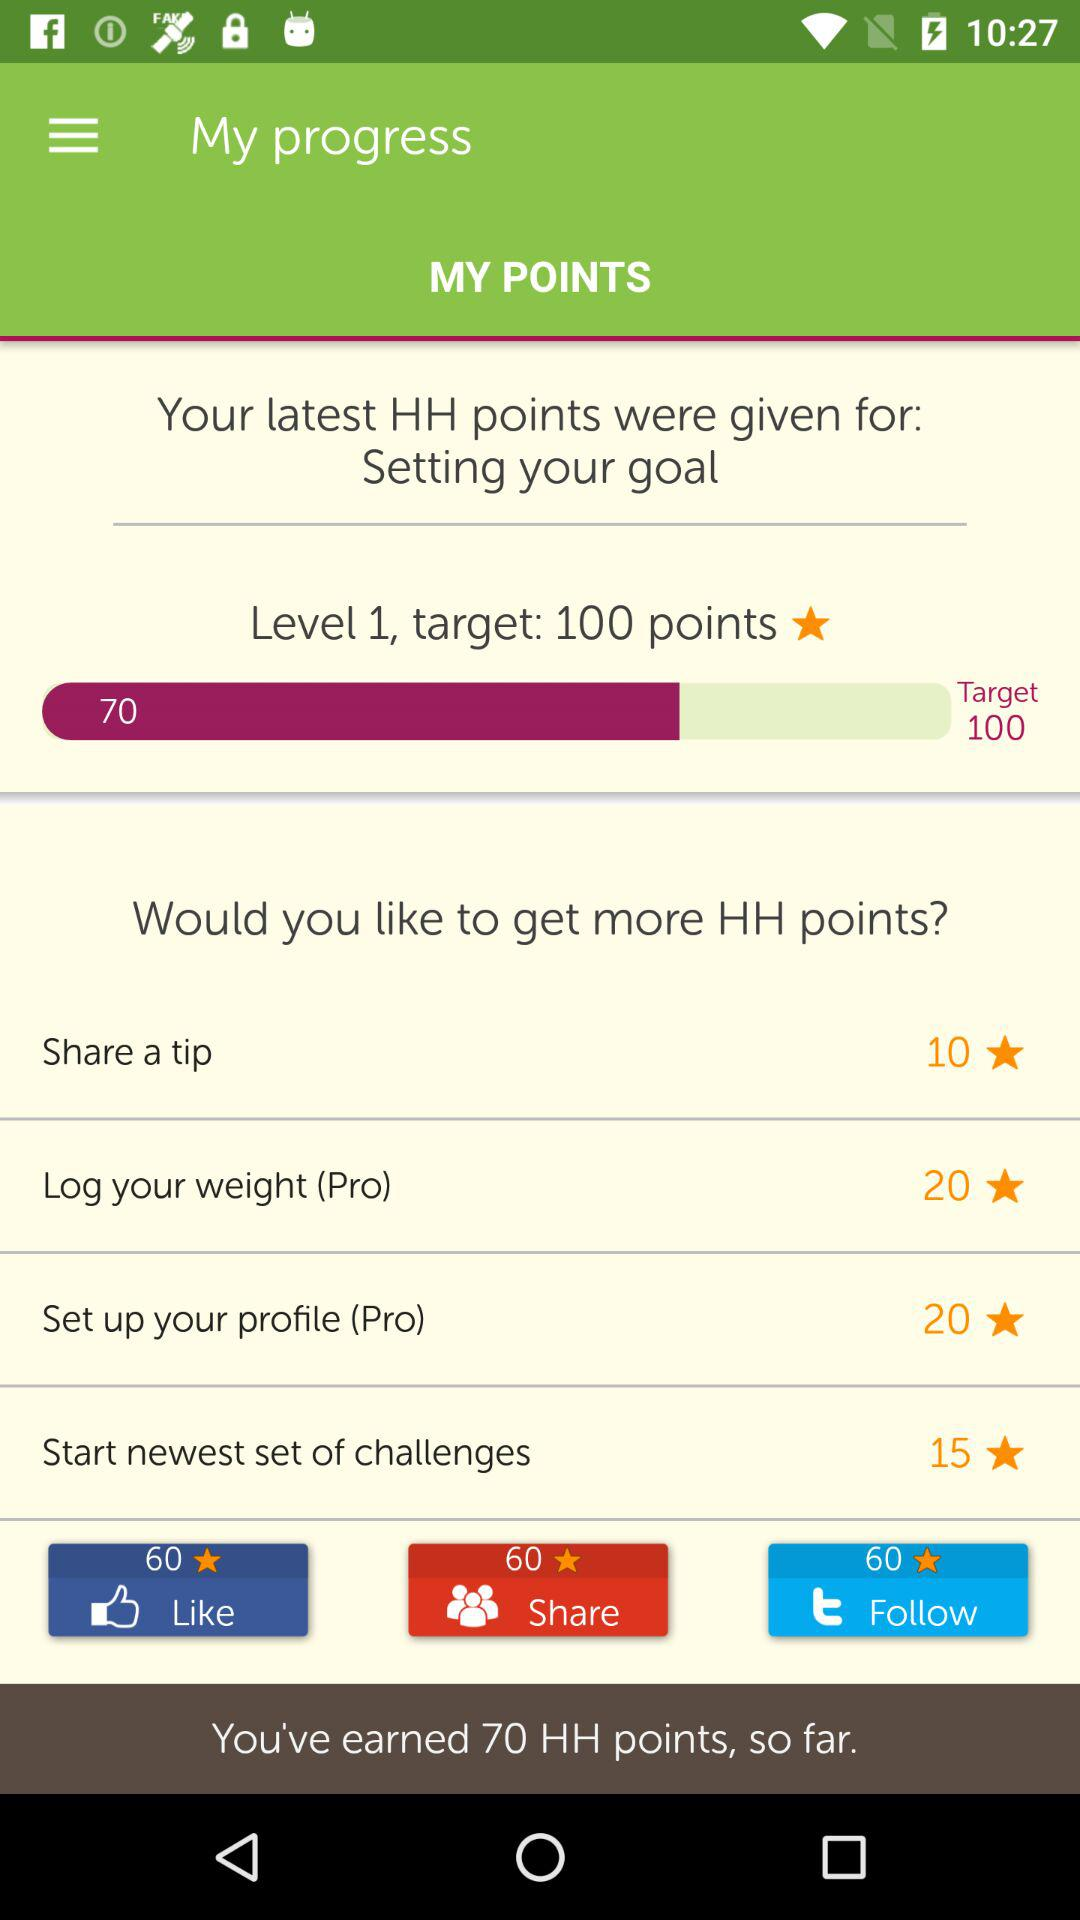What is the target? The target is 100 points. 